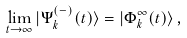<formula> <loc_0><loc_0><loc_500><loc_500>\lim _ { t \rightarrow \infty } | \Psi ^ { ( - ) } _ { k } ( t ) \rangle = | \Phi _ { k } ^ { \infty } ( t ) \rangle \, ,</formula> 